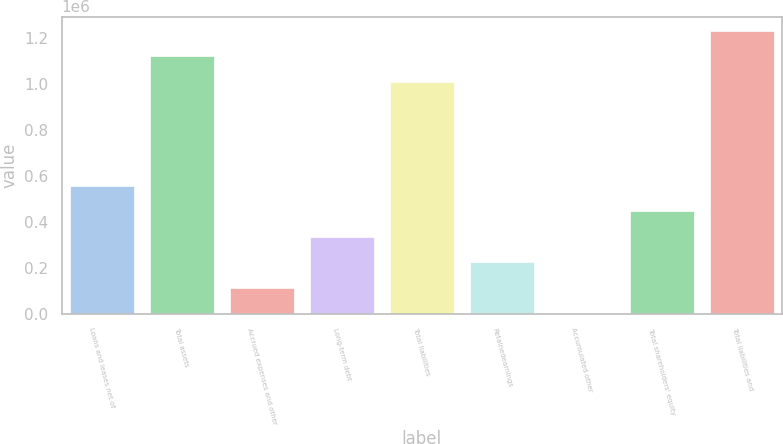<chart> <loc_0><loc_0><loc_500><loc_500><bar_chart><fcel>Loans and leases net of<fcel>Total assets<fcel>Accrued expenses and other<fcel>Long-term debt<fcel>Total liabilities<fcel>Retainedearnings<fcel>Accumulated other<fcel>Total shareholders' equity<fcel>Total liabilities and<nl><fcel>556598<fcel>1.12096e+06<fcel>113531<fcel>335064<fcel>1.0102e+06<fcel>224298<fcel>2764<fcel>445831<fcel>1.23173e+06<nl></chart> 